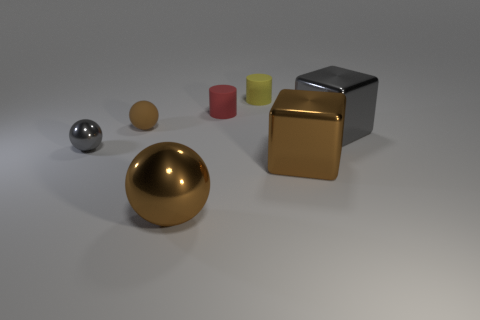Subtract all metallic balls. How many balls are left? 1 Subtract 1 balls. How many balls are left? 2 Add 2 big blue shiny objects. How many objects exist? 9 Subtract all spheres. How many objects are left? 4 Add 4 large objects. How many large objects are left? 7 Add 1 yellow metallic cylinders. How many yellow metallic cylinders exist? 1 Subtract 0 yellow balls. How many objects are left? 7 Subtract all big red objects. Subtract all small brown rubber things. How many objects are left? 6 